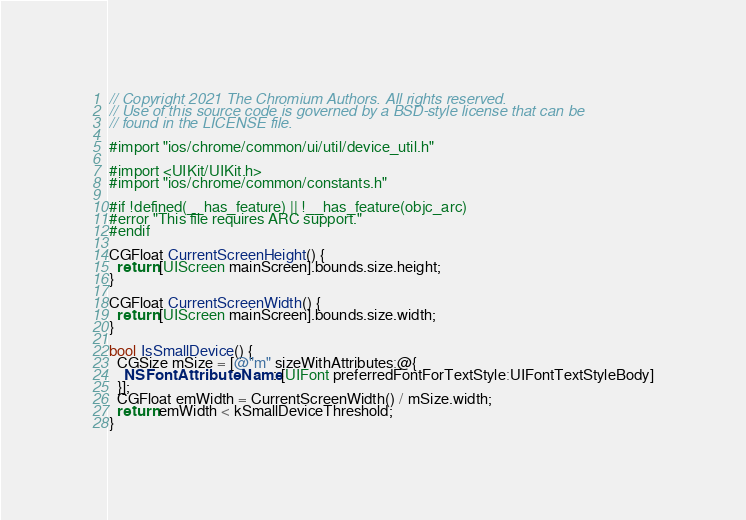<code> <loc_0><loc_0><loc_500><loc_500><_ObjectiveC_>// Copyright 2021 The Chromium Authors. All rights reserved.
// Use of this source code is governed by a BSD-style license that can be
// found in the LICENSE file.

#import "ios/chrome/common/ui/util/device_util.h"

#import <UIKit/UIKit.h>
#import "ios/chrome/common/constants.h"

#if !defined(__has_feature) || !__has_feature(objc_arc)
#error "This file requires ARC support."
#endif

CGFloat CurrentScreenHeight() {
  return [UIScreen mainScreen].bounds.size.height;
}

CGFloat CurrentScreenWidth() {
  return [UIScreen mainScreen].bounds.size.width;
}

bool IsSmallDevice() {
  CGSize mSize = [@"m" sizeWithAttributes:@{
    NSFontAttributeName : [UIFont preferredFontForTextStyle:UIFontTextStyleBody]
  }];
  CGFloat emWidth = CurrentScreenWidth() / mSize.width;
  return emWidth < kSmallDeviceThreshold;
}</code> 